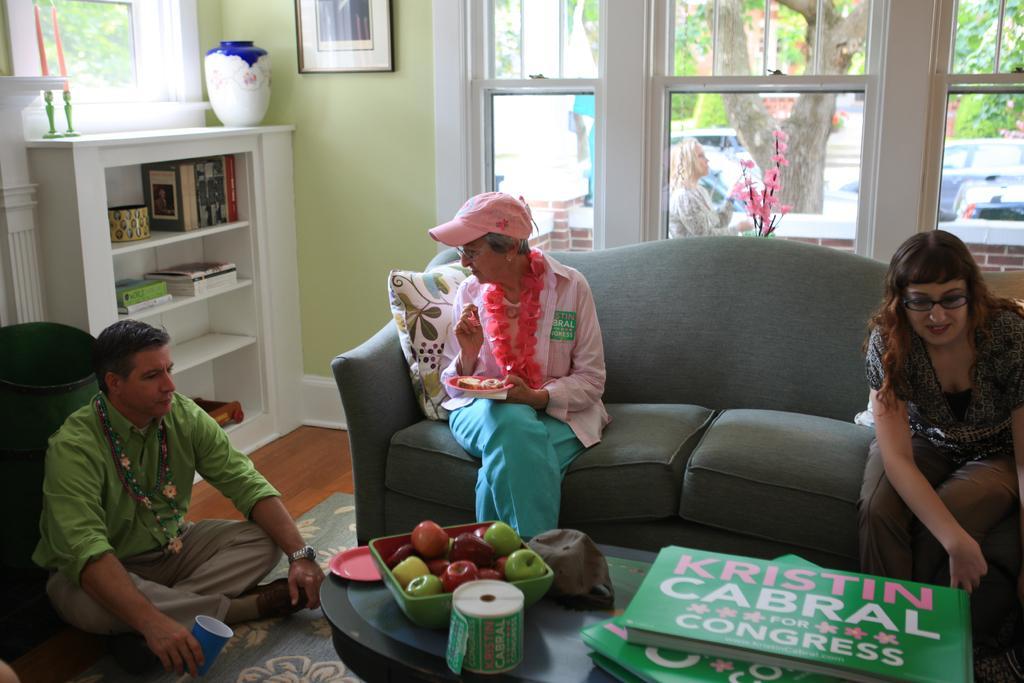Describe this image in one or two sentences. This picture is clicked inside. In the foreground there is a table on the top of which books, fruits and some other items are placed. On the left there is a person wearing green color shirt, holding a glass and sitting on the ground and we can see the two people sitting on a couch. On the left corner there is a cabinet containing picture frame, books and some other items and we can see a pot and a candle stand placed on the top of the cabinet. In the background we can see the windows and picture frame hanging on the wall and through the windows we can see a person, house plant, vehicles, trees and some other objects. 